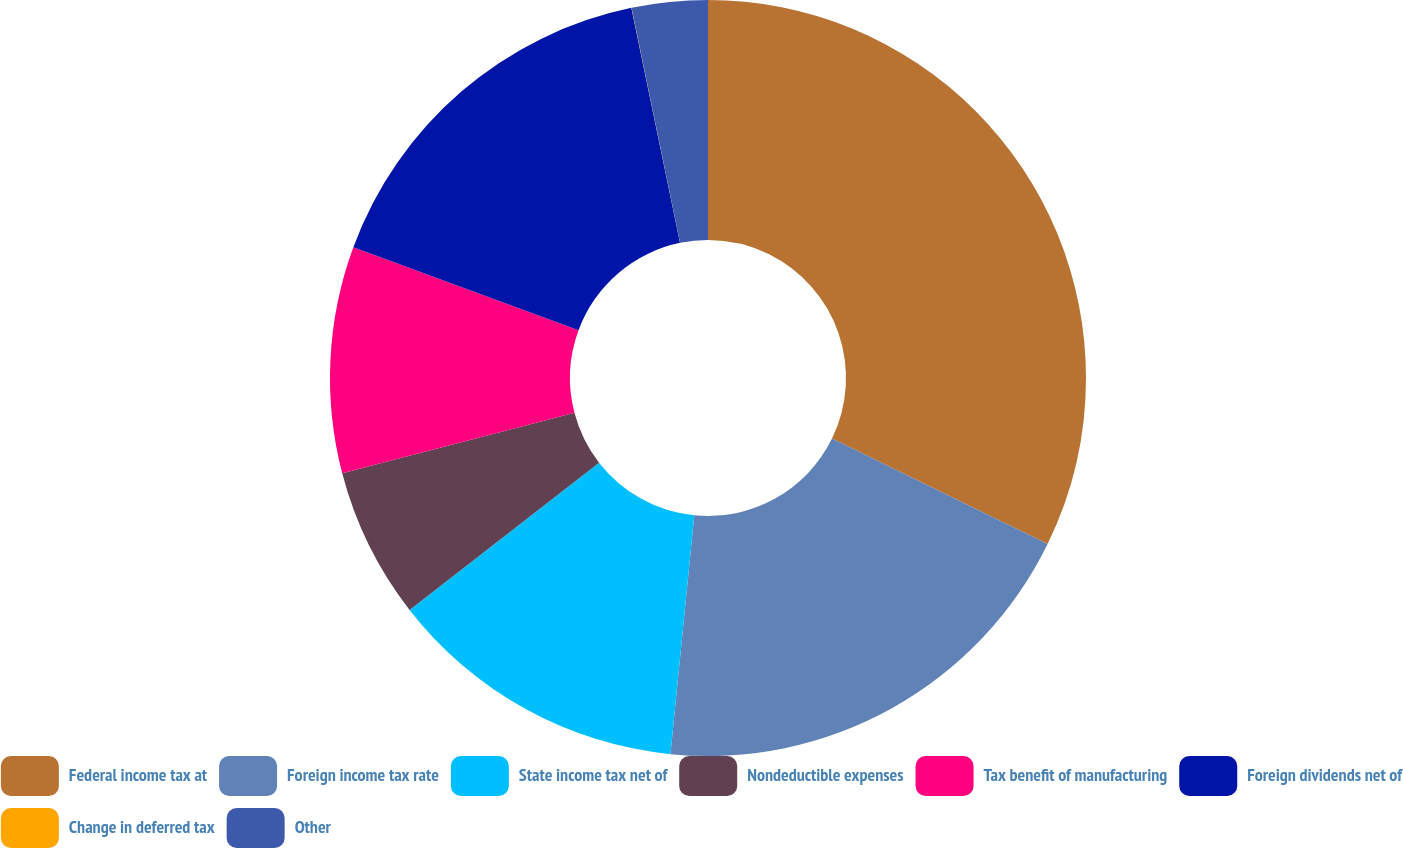Convert chart to OTSL. <chart><loc_0><loc_0><loc_500><loc_500><pie_chart><fcel>Federal income tax at<fcel>Foreign income tax rate<fcel>State income tax net of<fcel>Nondeductible expenses<fcel>Tax benefit of manufacturing<fcel>Foreign dividends net of<fcel>Change in deferred tax<fcel>Other<nl><fcel>32.24%<fcel>19.35%<fcel>12.9%<fcel>6.46%<fcel>9.68%<fcel>16.13%<fcel>0.01%<fcel>3.24%<nl></chart> 